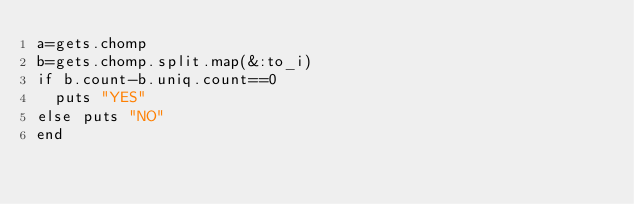<code> <loc_0><loc_0><loc_500><loc_500><_Ruby_>a=gets.chomp
b=gets.chomp.split.map(&:to_i)
if b.count-b.uniq.count==0
  puts "YES"
else puts "NO"
end</code> 